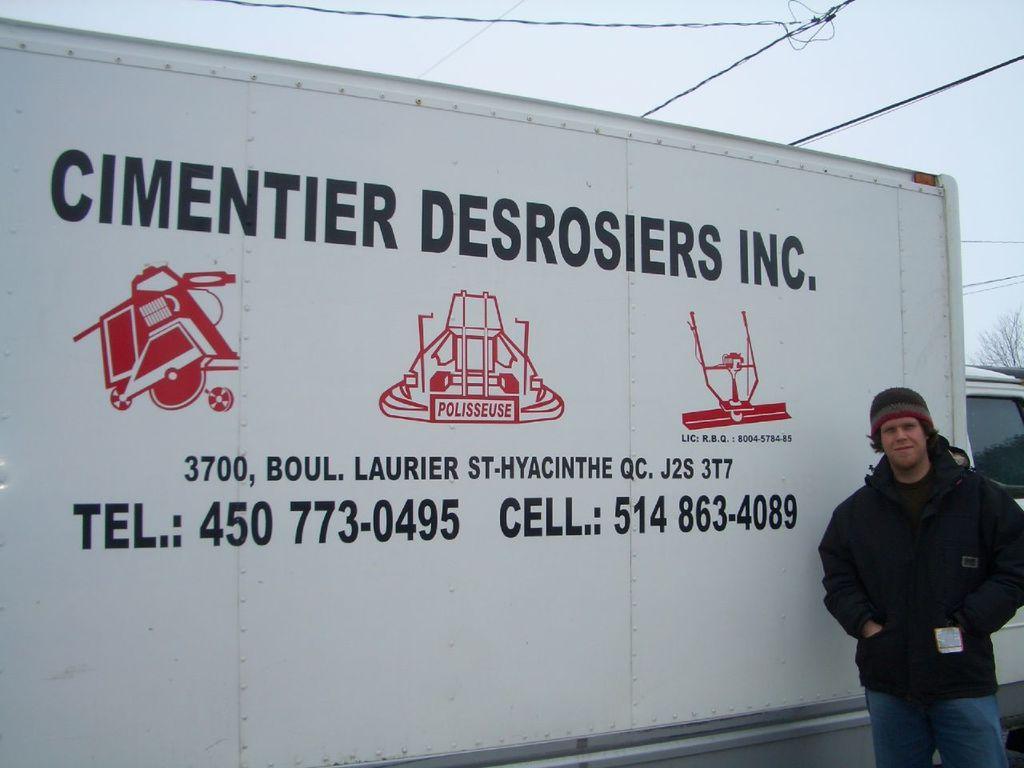Can you describe this image briefly? In this picture I can see the text and the images on a board in the middle. On the right side there is a man wearing a coat, at the top there is the sky. 